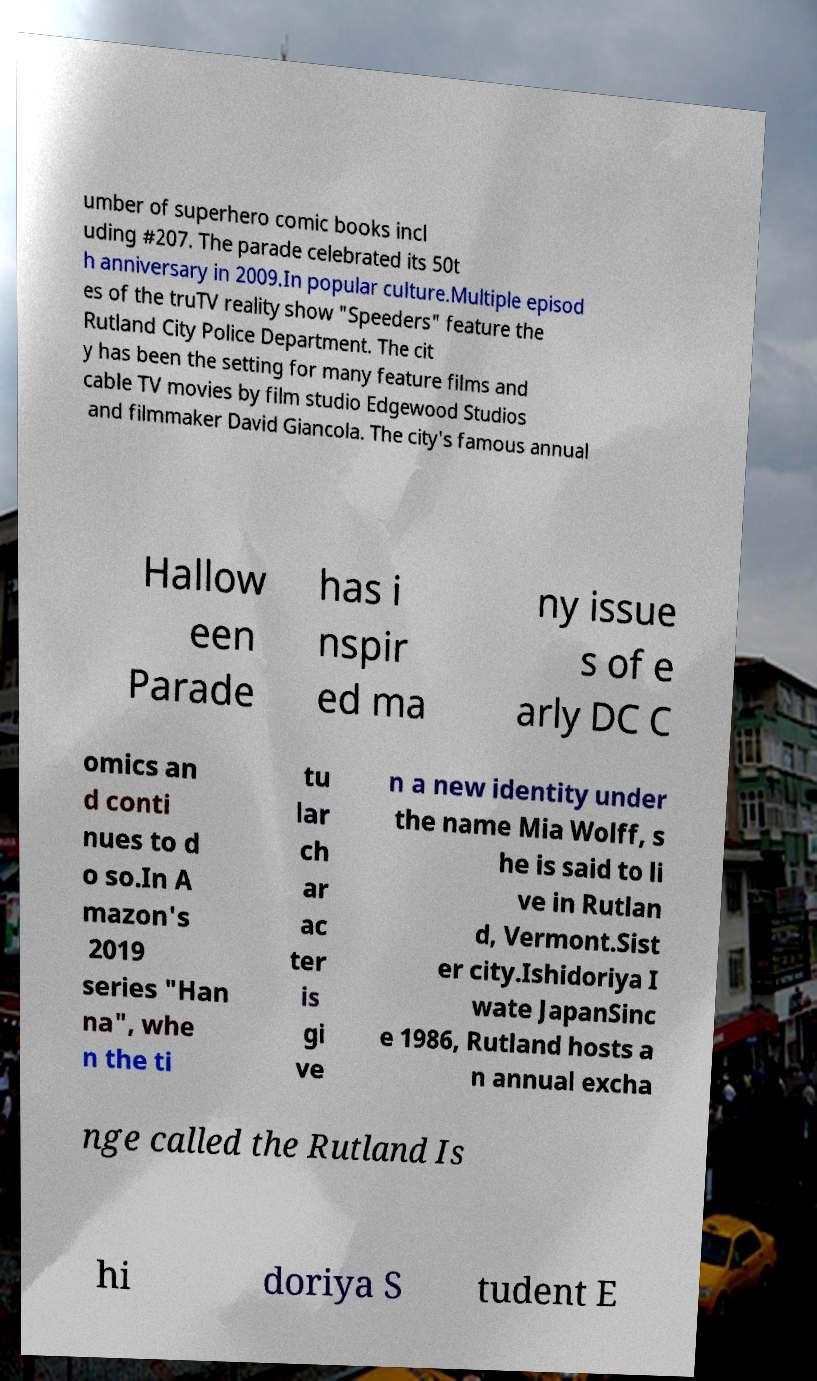What messages or text are displayed in this image? I need them in a readable, typed format. umber of superhero comic books incl uding #207. The parade celebrated its 50t h anniversary in 2009.In popular culture.Multiple episod es of the truTV reality show "Speeders" feature the Rutland City Police Department. The cit y has been the setting for many feature films and cable TV movies by film studio Edgewood Studios and filmmaker David Giancola. The city's famous annual Hallow een Parade has i nspir ed ma ny issue s of e arly DC C omics an d conti nues to d o so.In A mazon's 2019 series "Han na", whe n the ti tu lar ch ar ac ter is gi ve n a new identity under the name Mia Wolff, s he is said to li ve in Rutlan d, Vermont.Sist er city.Ishidoriya I wate JapanSinc e 1986, Rutland hosts a n annual excha nge called the Rutland Is hi doriya S tudent E 